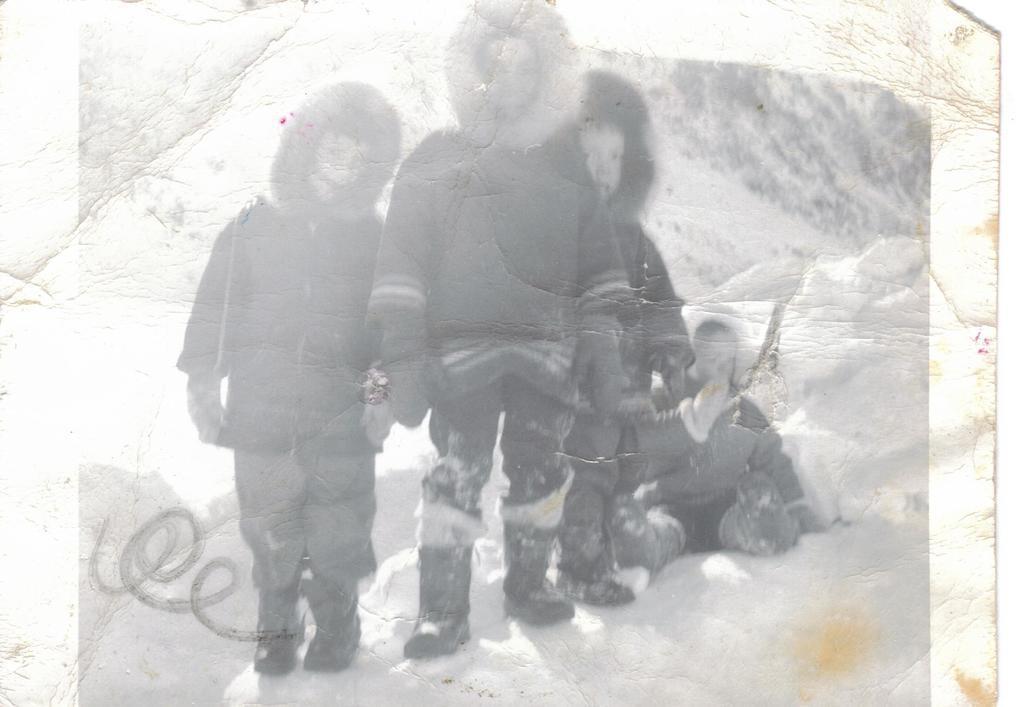Describe this image in one or two sentences. In this image we can see a black and white image. In this image we can see some children. In the background of the image there is a blur background. 